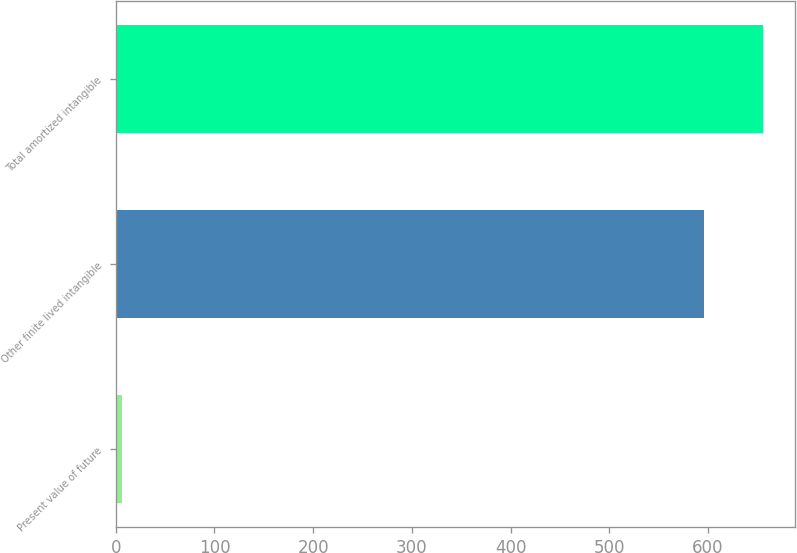<chart> <loc_0><loc_0><loc_500><loc_500><bar_chart><fcel>Present value of future<fcel>Other finite lived intangible<fcel>Total amortized intangible<nl><fcel>6.8<fcel>595.9<fcel>655.49<nl></chart> 